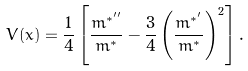Convert formula to latex. <formula><loc_0><loc_0><loc_500><loc_500>V ( x ) = \frac { 1 } { 4 } \left [ \frac { m ^ { * ^ { \prime \prime } } } { m ^ { * } } - \frac { 3 } { 4 } \left ( \frac { m ^ { * ^ { \prime } } } { m ^ { * } } \right ) ^ { 2 } \right ] .</formula> 